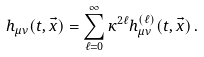<formula> <loc_0><loc_0><loc_500><loc_500>h _ { \mu \nu } ( t , \vec { x } ) = \sum _ { \ell = 0 } ^ { \infty } \kappa ^ { 2 \ell } h ^ { ( \ell ) } _ { \mu \nu } ( t , \vec { x } ) \, .</formula> 